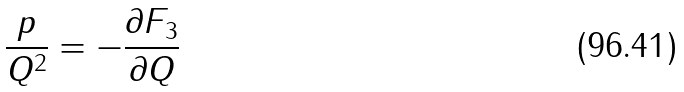<formula> <loc_0><loc_0><loc_500><loc_500>\frac { p } { Q ^ { 2 } } = - \frac { \partial F _ { 3 } } { \partial Q }</formula> 